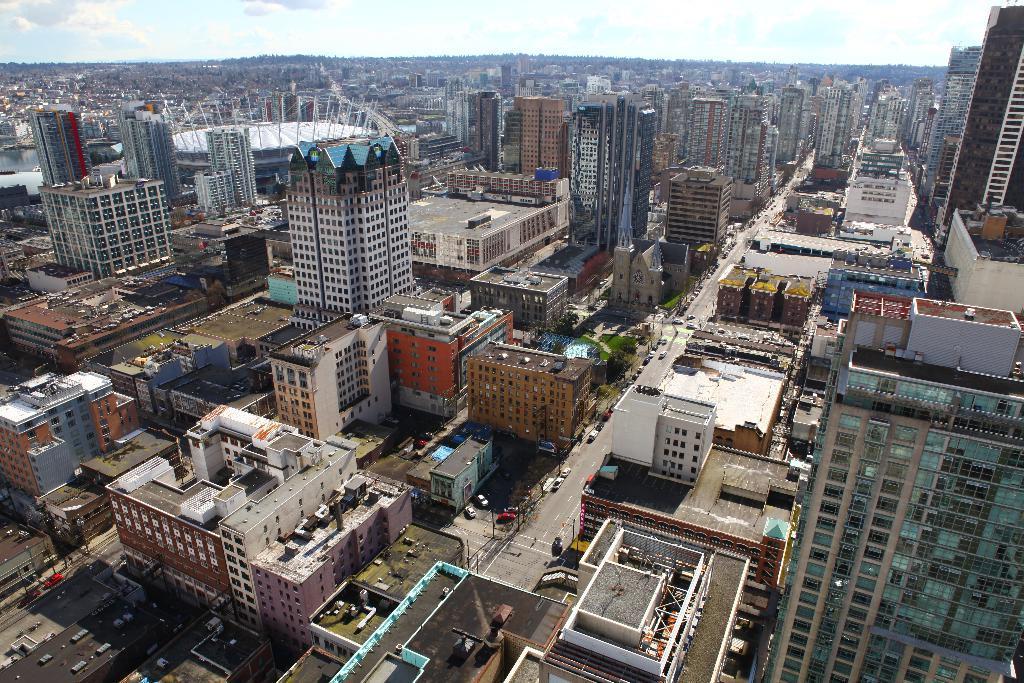Could you give a brief overview of what you see in this image? In this picture there are buildings and there are vehicles on the road and the sky is cloudy. 